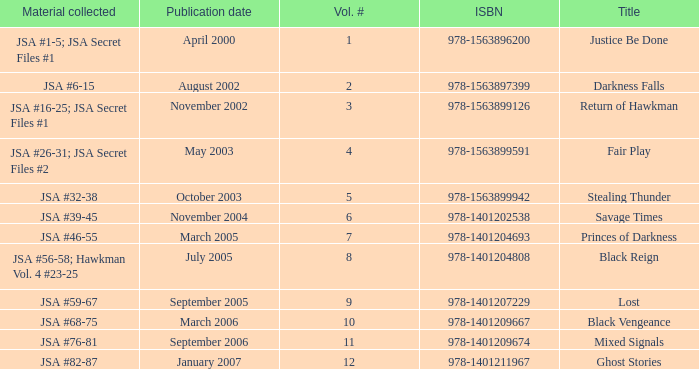How many Volume Numbers have the title of Darkness Falls? 2.0. 